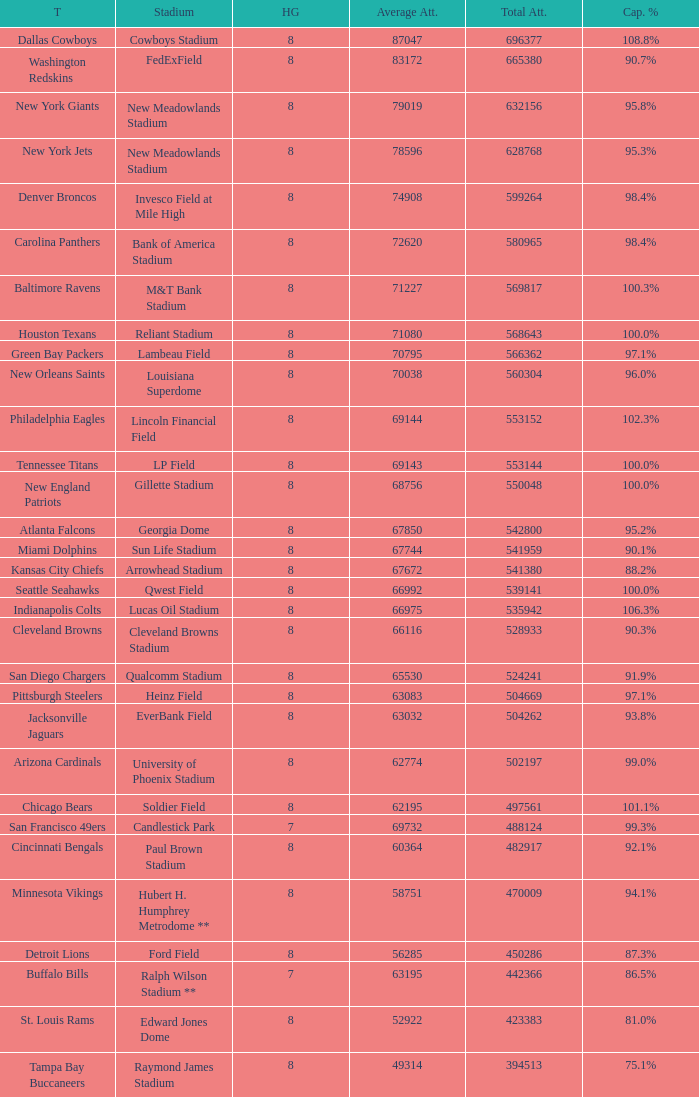What team had a capacity of 102.3%? Philadelphia Eagles. 